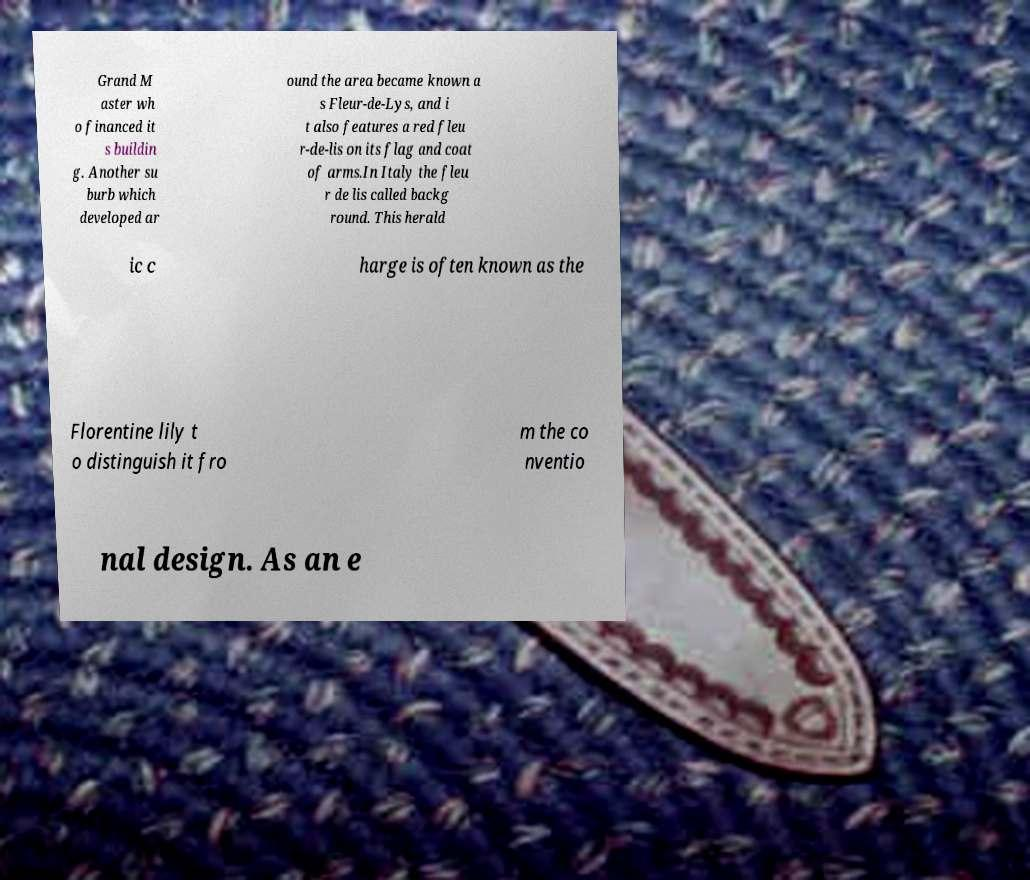Could you extract and type out the text from this image? Grand M aster wh o financed it s buildin g. Another su burb which developed ar ound the area became known a s Fleur-de-Lys, and i t also features a red fleu r-de-lis on its flag and coat of arms.In Italy the fleu r de lis called backg round. This herald ic c harge is often known as the Florentine lily t o distinguish it fro m the co nventio nal design. As an e 